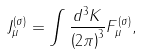Convert formula to latex. <formula><loc_0><loc_0><loc_500><loc_500>J ^ { ( \sigma ) } _ { \mu } = \int \frac { d ^ { 3 } K } { \left ( 2 \pi \right ) ^ { 3 } } F _ { \mu } ^ { ( \sigma ) } ,</formula> 